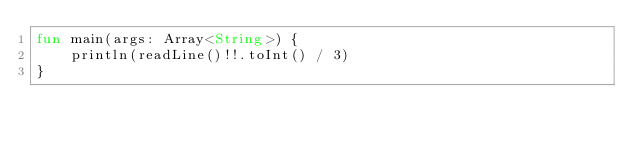<code> <loc_0><loc_0><loc_500><loc_500><_Kotlin_>fun main(args: Array<String>) {
    println(readLine()!!.toInt() / 3)
}</code> 